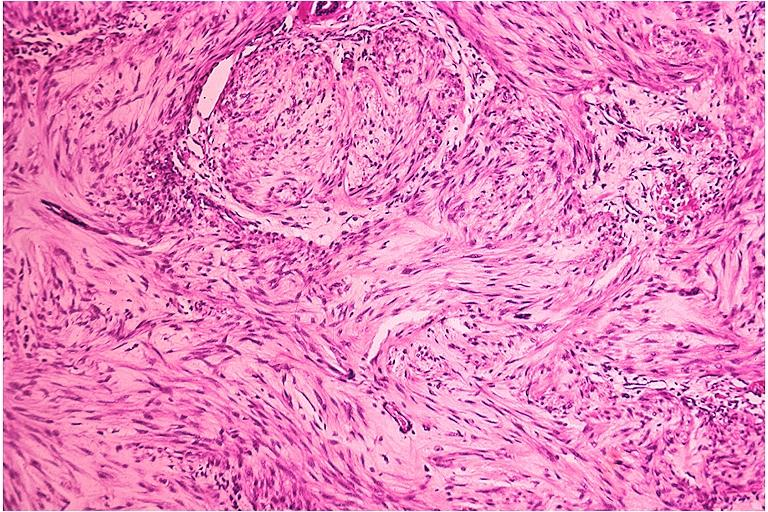what does this image show?
Answer the question using a single word or phrase. Neurofibroma 